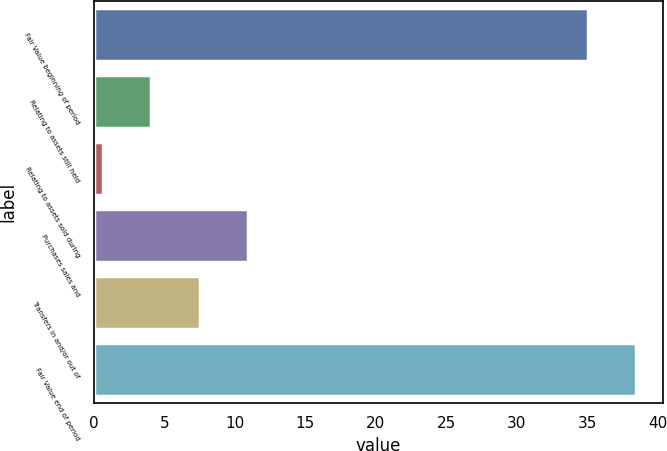Convert chart. <chart><loc_0><loc_0><loc_500><loc_500><bar_chart><fcel>Fair Value beginning of period<fcel>Relating to assets still held<fcel>Relating to assets sold during<fcel>Purchases sales and<fcel>Transfers in and/or out of<fcel>Fair Value end of period<nl><fcel>35<fcel>4.06<fcel>0.62<fcel>10.94<fcel>7.5<fcel>38.44<nl></chart> 